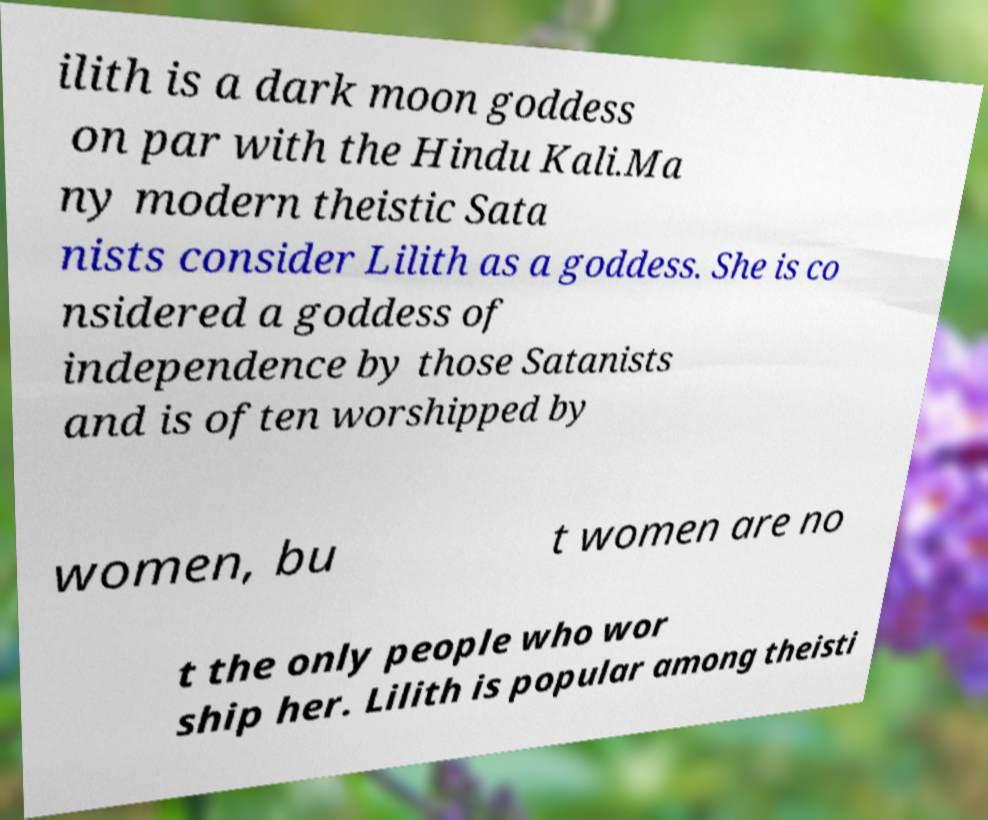What messages or text are displayed in this image? I need them in a readable, typed format. ilith is a dark moon goddess on par with the Hindu Kali.Ma ny modern theistic Sata nists consider Lilith as a goddess. She is co nsidered a goddess of independence by those Satanists and is often worshipped by women, bu t women are no t the only people who wor ship her. Lilith is popular among theisti 